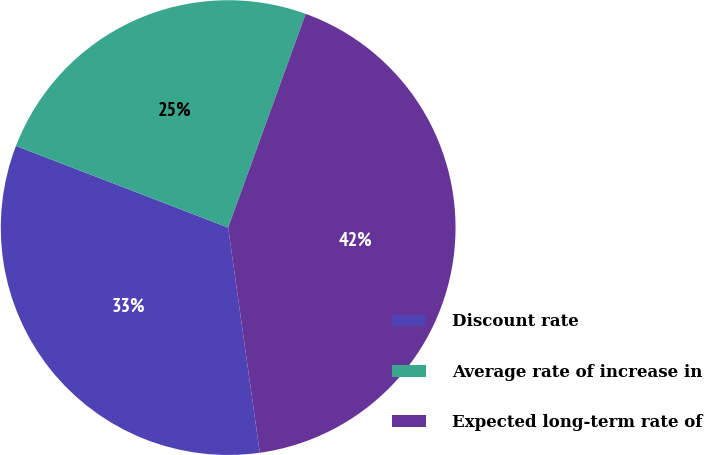Convert chart to OTSL. <chart><loc_0><loc_0><loc_500><loc_500><pie_chart><fcel>Discount rate<fcel>Average rate of increase in<fcel>Expected long-term rate of<nl><fcel>33.07%<fcel>24.69%<fcel>42.24%<nl></chart> 